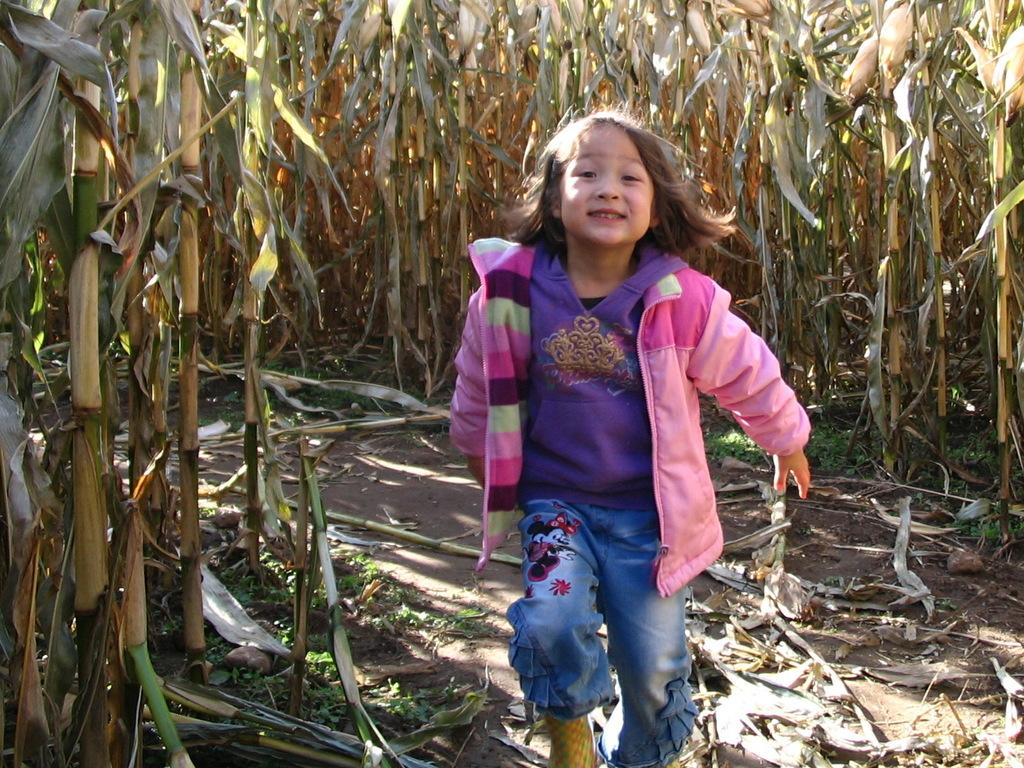What type of material is present on the ground in the image? There are shredded leaves on the ground in the image. What is the girl in the image doing? The girl is standing on the ground in the image. What can be seen in the background of the image? There is an agricultural farm in the background of the image. What is the value of the sky in the image? The sky is not assigned a value in the image; it is simply a part of the background. Can you describe the downtown area in the image? There is no downtown area present in the image; it features a girl standing on shredded leaves with an agricultural farm in the background. 